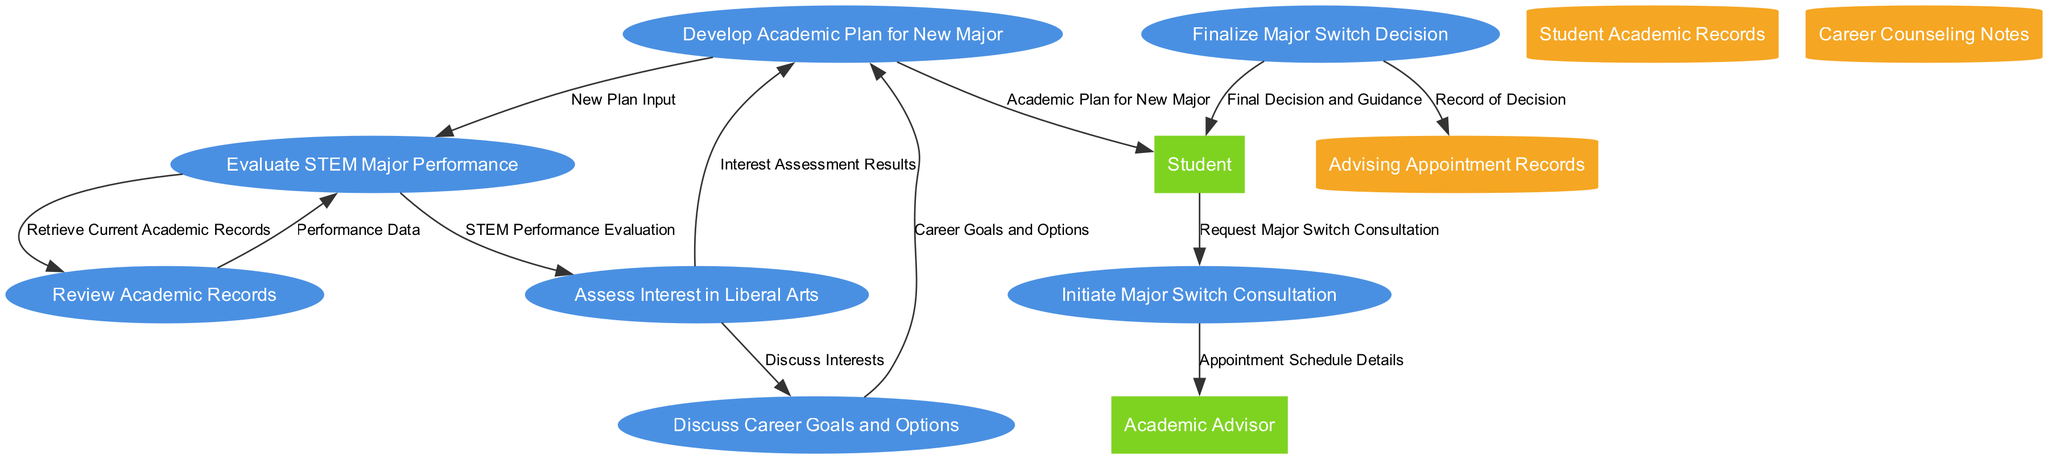What is the first process in the diagram? The first process listed is "Initiate Major Switch Consultation", which is represented as process 1 in the diagram.
Answer: Initiate Major Switch Consultation How many data stores are present in the diagram? The diagram lists three data stores: "Student Academic Records", "Career Counseling Notes", and "Advising Appointment Records". Therefore, there are three data stores present.
Answer: 3 What data flow comes from the student? The data flow from the student is labeled "Request Major Switch Consultation", leading to the first process.
Answer: Request Major Switch Consultation What are the names of the external entities? The diagram features two external entities: "Student" and "Academic Advisor". These are the entities that interact with the processes.
Answer: Student, Academic Advisor Which process receives "Interest Assessment Results"? The "Assess Interest in Liberal Arts" process receives the "Interest Assessment Results", which are derived from the evaluation of interest in liberal arts.
Answer: Assess Interest in Liberal Arts What happens after discussing career goals and options? After the discussion of career goals and options, the flow moves to the "Develop Academic Plan for New Major" process, indicating that the discussion informs the planning.
Answer: Develop Academic Plan for New Major What is the relationship between the processes assessing interest in liberal arts and discussing career goals? The "Assess Interest in Liberal Arts" process produces outputs to both "Develop Academic Plan for New Major" and "Discuss Career Goals and Options", indicating these are parallel processes informed by the assessment.
Answer: Parallel processes What is recorded in the Advising Appointment Records? The result of the "Finalize Major Switch Decision" process leads to the data flow labeled "Record of Decision", which is stored in the "Advising Appointment Records".
Answer: Record of Decision 